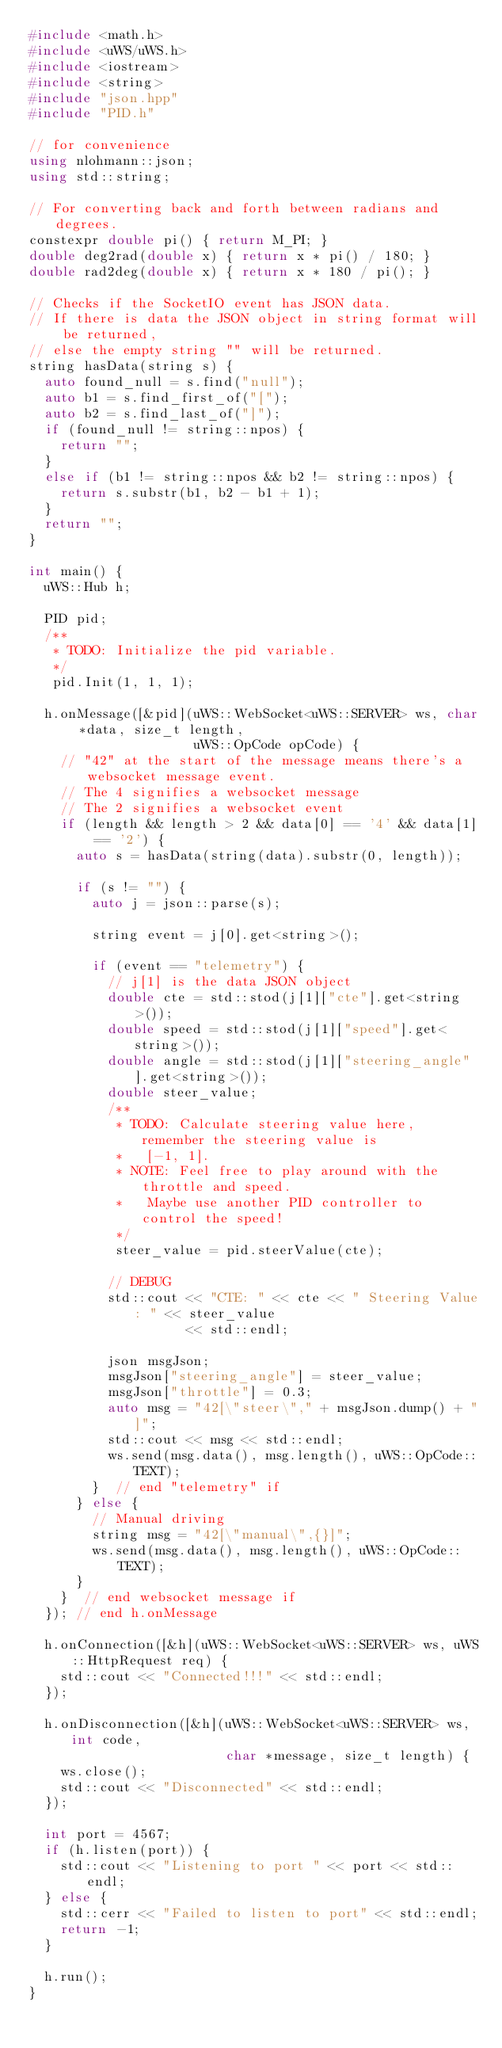Convert code to text. <code><loc_0><loc_0><loc_500><loc_500><_C++_>#include <math.h>
#include <uWS/uWS.h>
#include <iostream>
#include <string>
#include "json.hpp"
#include "PID.h"

// for convenience
using nlohmann::json;
using std::string;

// For converting back and forth between radians and degrees.
constexpr double pi() { return M_PI; }
double deg2rad(double x) { return x * pi() / 180; }
double rad2deg(double x) { return x * 180 / pi(); }

// Checks if the SocketIO event has JSON data.
// If there is data the JSON object in string format will be returned,
// else the empty string "" will be returned.
string hasData(string s) {
  auto found_null = s.find("null");
  auto b1 = s.find_first_of("[");
  auto b2 = s.find_last_of("]");
  if (found_null != string::npos) {
    return "";
  }
  else if (b1 != string::npos && b2 != string::npos) {
    return s.substr(b1, b2 - b1 + 1);
  }
  return "";
}

int main() {
  uWS::Hub h;

  PID pid;
  /**
   * TODO: Initialize the pid variable.
   */
   pid.Init(1, 1, 1);

  h.onMessage([&pid](uWS::WebSocket<uWS::SERVER> ws, char *data, size_t length, 
                     uWS::OpCode opCode) {
    // "42" at the start of the message means there's a websocket message event.
    // The 4 signifies a websocket message
    // The 2 signifies a websocket event
    if (length && length > 2 && data[0] == '4' && data[1] == '2') {
      auto s = hasData(string(data).substr(0, length));

      if (s != "") {
        auto j = json::parse(s);

        string event = j[0].get<string>();

        if (event == "telemetry") {
          // j[1] is the data JSON object
          double cte = std::stod(j[1]["cte"].get<string>());
          double speed = std::stod(j[1]["speed"].get<string>());
          double angle = std::stod(j[1]["steering_angle"].get<string>());
          double steer_value;
          /**
           * TODO: Calculate steering value here, remember the steering value is
           *   [-1, 1].
           * NOTE: Feel free to play around with the throttle and speed.
           *   Maybe use another PID controller to control the speed!
           */
           steer_value = pid.steerValue(cte);
          
          // DEBUG
          std::cout << "CTE: " << cte << " Steering Value: " << steer_value 
                    << std::endl;

          json msgJson;
          msgJson["steering_angle"] = steer_value;
          msgJson["throttle"] = 0.3;
          auto msg = "42[\"steer\"," + msgJson.dump() + "]";
          std::cout << msg << std::endl;
          ws.send(msg.data(), msg.length(), uWS::OpCode::TEXT);
        }  // end "telemetry" if
      } else {
        // Manual driving
        string msg = "42[\"manual\",{}]";
        ws.send(msg.data(), msg.length(), uWS::OpCode::TEXT);
      }
    }  // end websocket message if
  }); // end h.onMessage

  h.onConnection([&h](uWS::WebSocket<uWS::SERVER> ws, uWS::HttpRequest req) {
    std::cout << "Connected!!!" << std::endl;
  });

  h.onDisconnection([&h](uWS::WebSocket<uWS::SERVER> ws, int code, 
                         char *message, size_t length) {
    ws.close();
    std::cout << "Disconnected" << std::endl;
  });

  int port = 4567;
  if (h.listen(port)) {
    std::cout << "Listening to port " << port << std::endl;
  } else {
    std::cerr << "Failed to listen to port" << std::endl;
    return -1;
  }
  
  h.run();
}</code> 